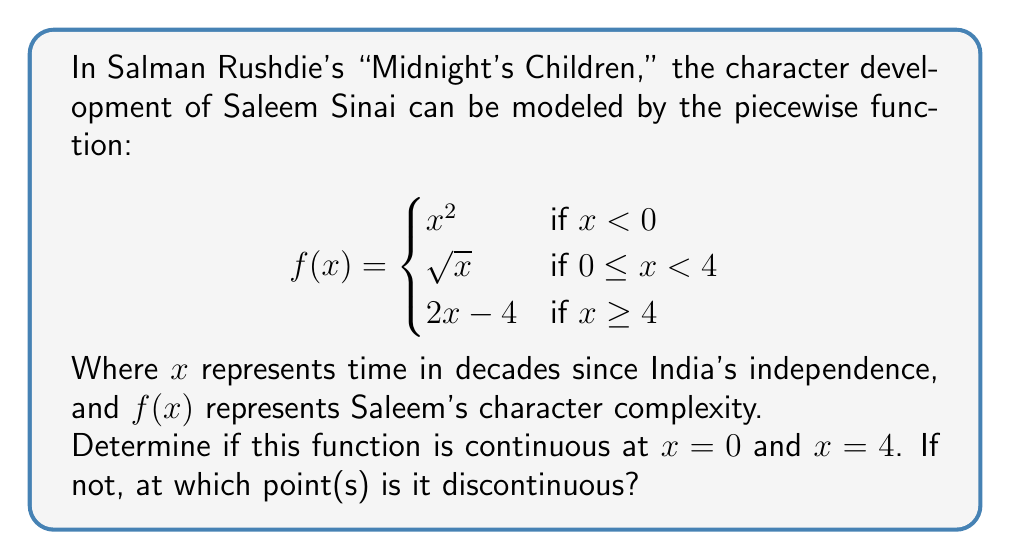Can you answer this question? To determine continuity at $x = 0$ and $x = 4$, we need to check three conditions at each point:
1. The function is defined at the point.
2. The limit of the function exists as we approach the point from both sides.
3. The limit equals the function value at that point.

For $x = 0$:
1. $f(0)$ is defined: $f(0) = \sqrt{0} = 0$
2. Left-hand limit: $\lim_{x \to 0^-} x^2 = 0$
   Right-hand limit: $\lim_{x \to 0^+} \sqrt{x} = 0$
3. $\lim_{x \to 0} f(x) = f(0) = 0$

All conditions are met, so $f(x)$ is continuous at $x = 0$.

For $x = 4$:
1. $f(4)$ is defined: $f(4) = 2(4) - 4 = 4$
2. Left-hand limit: $\lim_{x \to 4^-} \sqrt{x} = 2$
   Right-hand limit: $\lim_{x \to 4^+} (2x - 4) = 4$
3. $\lim_{x \to 4^-} f(x) \neq \lim_{x \to 4^+} f(x)$

The left-hand and right-hand limits are not equal at $x = 4$, so $f(x)$ is not continuous at $x = 4$.
Answer: $f(x)$ is continuous at $x = 0$ but discontinuous at $x = 4$. 